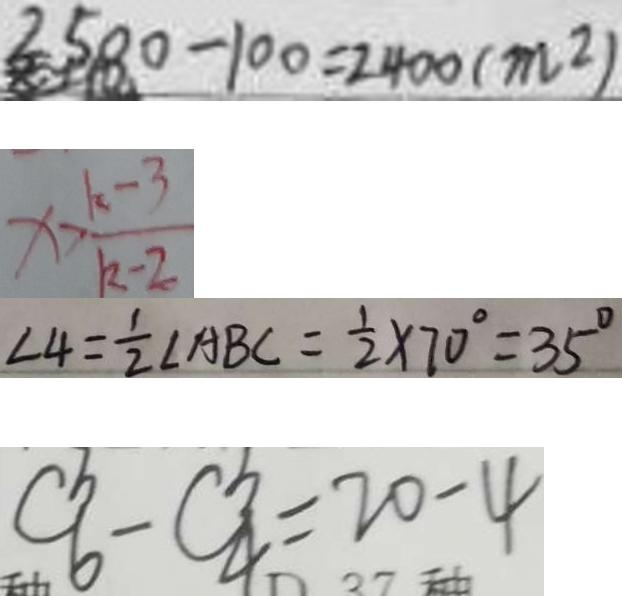Convert formula to latex. <formula><loc_0><loc_0><loc_500><loc_500>2 5 8 0 - 1 0 0 = 2 4 0 0 ( m ^ { 2 } ) 
 x > \frac { k - 3 } { k - 2 } 
 \angle 4 = \frac { 1 } { 2 } \angle A B C = \frac { 1 } { 2 } \times 7 0 ^ { \circ } = 3 5 ^ { \circ } 
 C ^ { b } _ { 6 } - C ^ { b } _ { 4 } = 2 0 - 4</formula> 